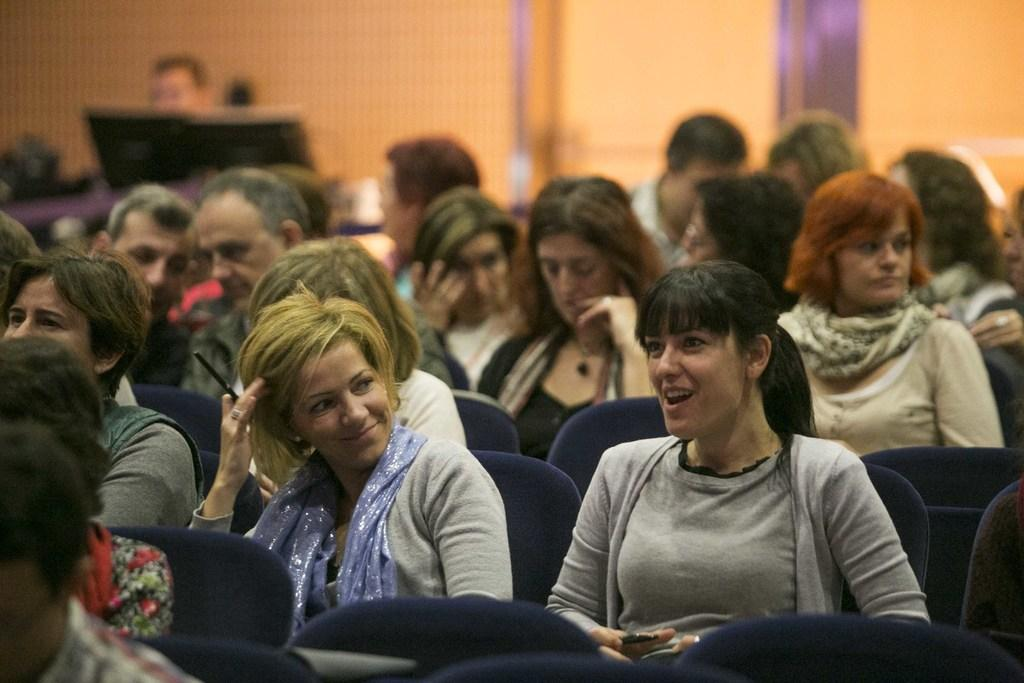What is the main subject of the image? There is a beautiful woman in the image. What is the woman doing in the image? The woman is sitting on a chair. What is the woman wearing in the image? The woman is wearing a t-shirt. What is the woman's facial expression in the image? The woman is smiling. Are there any other people in the image? Yes, there are other people sitting on chairs in the image. How many grapes can be seen on the hill in the image? There are no grapes or hills present in the image; it features a woman sitting on a chair and other people sitting nearby. 